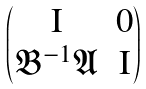Convert formula to latex. <formula><loc_0><loc_0><loc_500><loc_500>\begin{pmatrix} \mathrm I & 0 \\ \mathfrak B ^ { - 1 } \mathfrak A & \mathrm I \end{pmatrix}</formula> 